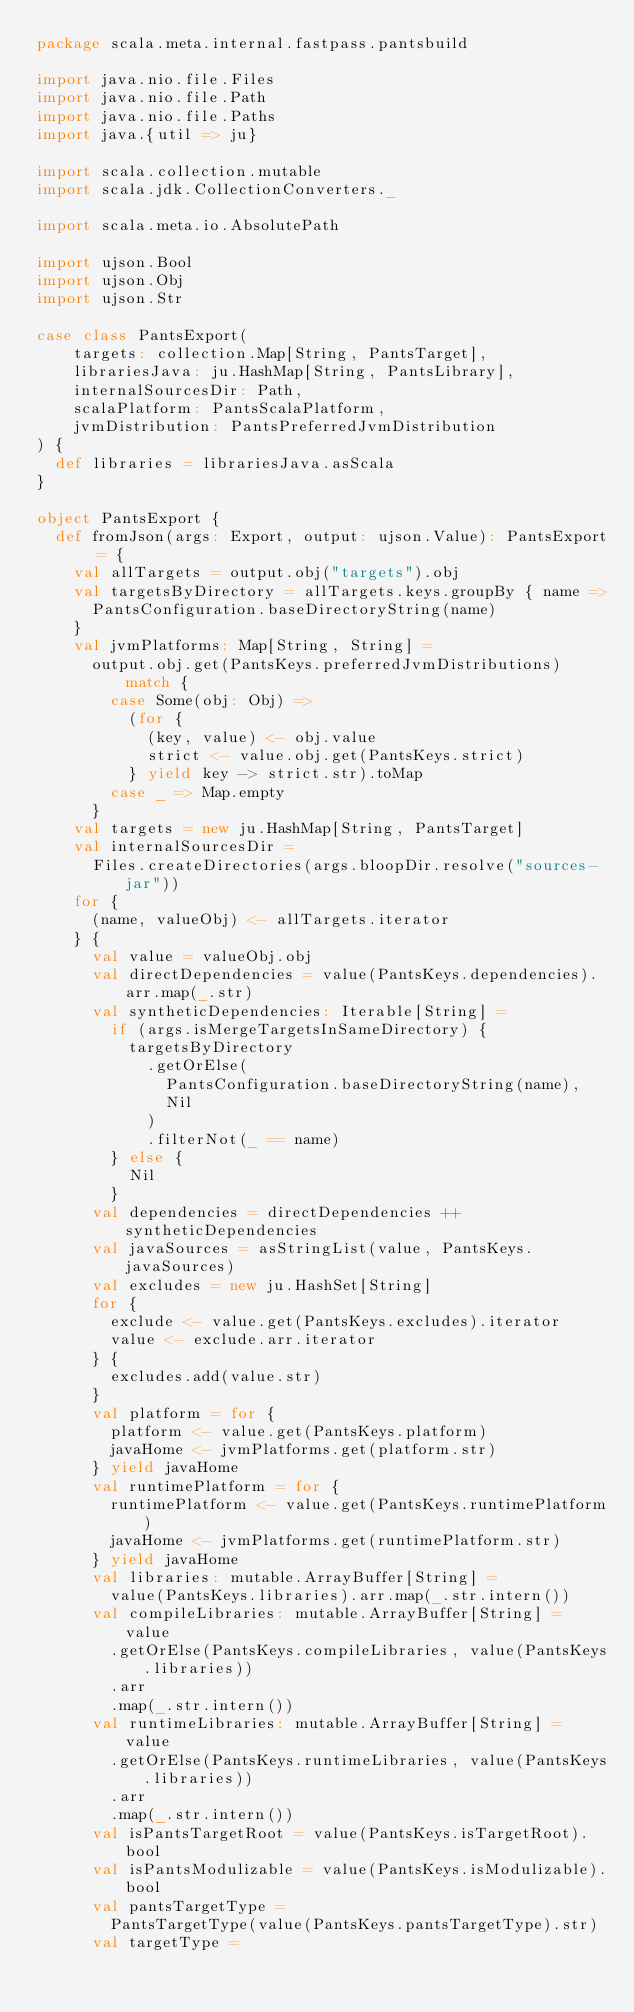Convert code to text. <code><loc_0><loc_0><loc_500><loc_500><_Scala_>package scala.meta.internal.fastpass.pantsbuild

import java.nio.file.Files
import java.nio.file.Path
import java.nio.file.Paths
import java.{util => ju}

import scala.collection.mutable
import scala.jdk.CollectionConverters._

import scala.meta.io.AbsolutePath

import ujson.Bool
import ujson.Obj
import ujson.Str

case class PantsExport(
    targets: collection.Map[String, PantsTarget],
    librariesJava: ju.HashMap[String, PantsLibrary],
    internalSourcesDir: Path,
    scalaPlatform: PantsScalaPlatform,
    jvmDistribution: PantsPreferredJvmDistribution
) {
  def libraries = librariesJava.asScala
}

object PantsExport {
  def fromJson(args: Export, output: ujson.Value): PantsExport = {
    val allTargets = output.obj("targets").obj
    val targetsByDirectory = allTargets.keys.groupBy { name =>
      PantsConfiguration.baseDirectoryString(name)
    }
    val jvmPlatforms: Map[String, String] =
      output.obj.get(PantsKeys.preferredJvmDistributions) match {
        case Some(obj: Obj) =>
          (for {
            (key, value) <- obj.value
            strict <- value.obj.get(PantsKeys.strict)
          } yield key -> strict.str).toMap
        case _ => Map.empty
      }
    val targets = new ju.HashMap[String, PantsTarget]
    val internalSourcesDir =
      Files.createDirectories(args.bloopDir.resolve("sources-jar"))
    for {
      (name, valueObj) <- allTargets.iterator
    } {
      val value = valueObj.obj
      val directDependencies = value(PantsKeys.dependencies).arr.map(_.str)
      val syntheticDependencies: Iterable[String] =
        if (args.isMergeTargetsInSameDirectory) {
          targetsByDirectory
            .getOrElse(
              PantsConfiguration.baseDirectoryString(name),
              Nil
            )
            .filterNot(_ == name)
        } else {
          Nil
        }
      val dependencies = directDependencies ++ syntheticDependencies
      val javaSources = asStringList(value, PantsKeys.javaSources)
      val excludes = new ju.HashSet[String]
      for {
        exclude <- value.get(PantsKeys.excludes).iterator
        value <- exclude.arr.iterator
      } {
        excludes.add(value.str)
      }
      val platform = for {
        platform <- value.get(PantsKeys.platform)
        javaHome <- jvmPlatforms.get(platform.str)
      } yield javaHome
      val runtimePlatform = for {
        runtimePlatform <- value.get(PantsKeys.runtimePlatform)
        javaHome <- jvmPlatforms.get(runtimePlatform.str)
      } yield javaHome
      val libraries: mutable.ArrayBuffer[String] =
        value(PantsKeys.libraries).arr.map(_.str.intern())
      val compileLibraries: mutable.ArrayBuffer[String] = value
        .getOrElse(PantsKeys.compileLibraries, value(PantsKeys.libraries))
        .arr
        .map(_.str.intern())
      val runtimeLibraries: mutable.ArrayBuffer[String] = value
        .getOrElse(PantsKeys.runtimeLibraries, value(PantsKeys.libraries))
        .arr
        .map(_.str.intern())
      val isPantsTargetRoot = value(PantsKeys.isTargetRoot).bool
      val isPantsModulizable = value(PantsKeys.isModulizable).bool
      val pantsTargetType =
        PantsTargetType(value(PantsKeys.pantsTargetType).str)
      val targetType =</code> 